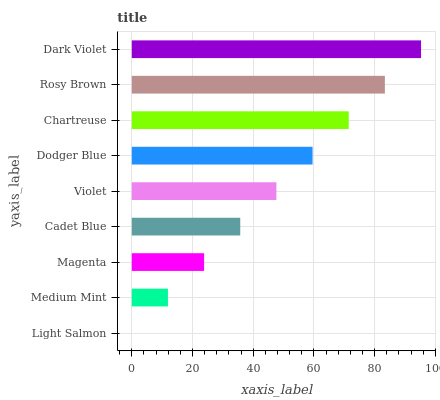Is Light Salmon the minimum?
Answer yes or no. Yes. Is Dark Violet the maximum?
Answer yes or no. Yes. Is Medium Mint the minimum?
Answer yes or no. No. Is Medium Mint the maximum?
Answer yes or no. No. Is Medium Mint greater than Light Salmon?
Answer yes or no. Yes. Is Light Salmon less than Medium Mint?
Answer yes or no. Yes. Is Light Salmon greater than Medium Mint?
Answer yes or no. No. Is Medium Mint less than Light Salmon?
Answer yes or no. No. Is Violet the high median?
Answer yes or no. Yes. Is Violet the low median?
Answer yes or no. Yes. Is Medium Mint the high median?
Answer yes or no. No. Is Magenta the low median?
Answer yes or no. No. 